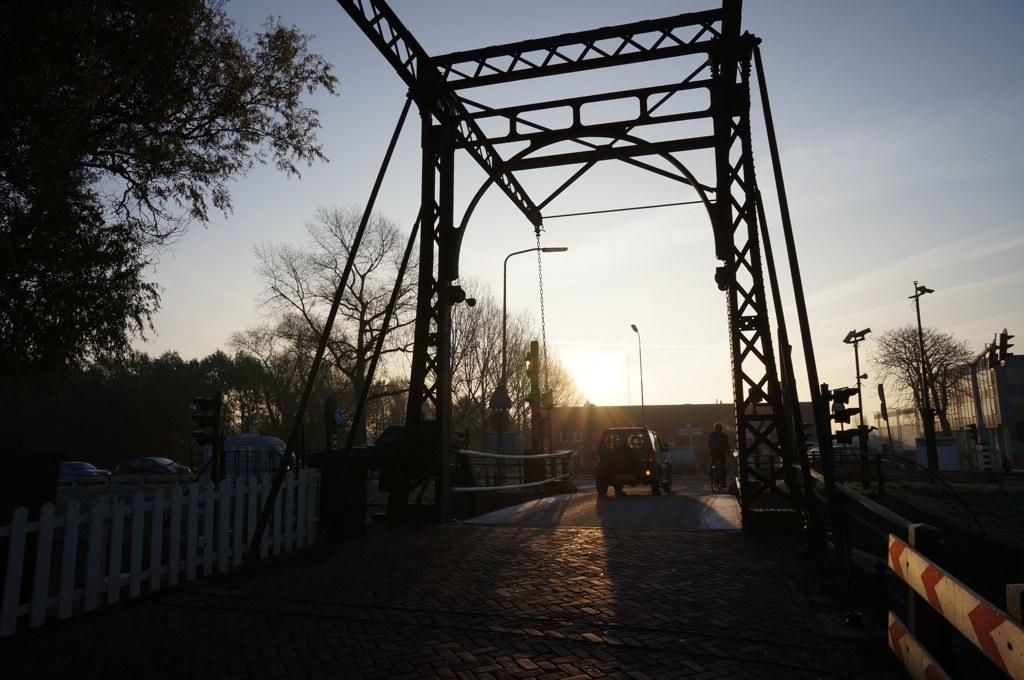What type of natural elements can be seen in the image? There are trees in the image. What type of man-made structures are visible in the image? There are vehicles on the road, light poles, a fence, and an arch in the image. Can you describe the person in the image? There is a person in the image, but their specific appearance or actions are not mentioned in the facts. What is visible at the top of the image? The sky is visible at the top of the image. Can you tell me how much salt is being used in the field in the image? There is no field or salt present in the image; it features trees, vehicles, light poles, a fence, an arch, and a person. Is there any steam coming from the vehicles in the image? The facts provided do not mention any steam coming from the vehicles in the image. 